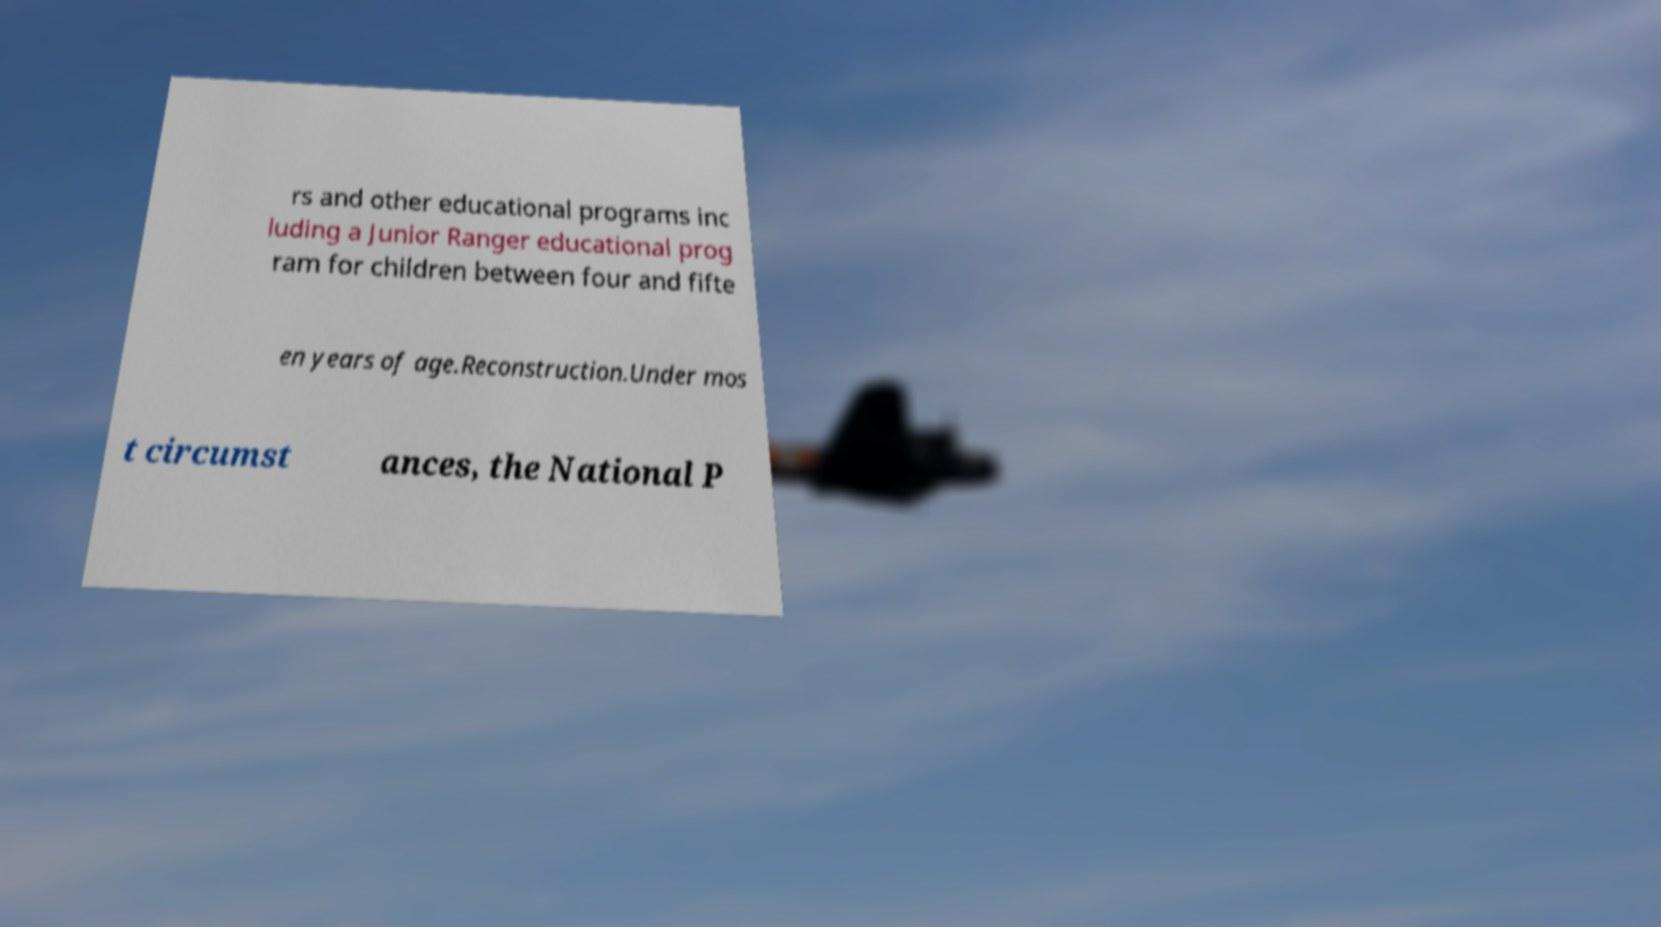Could you assist in decoding the text presented in this image and type it out clearly? rs and other educational programs inc luding a Junior Ranger educational prog ram for children between four and fifte en years of age.Reconstruction.Under mos t circumst ances, the National P 